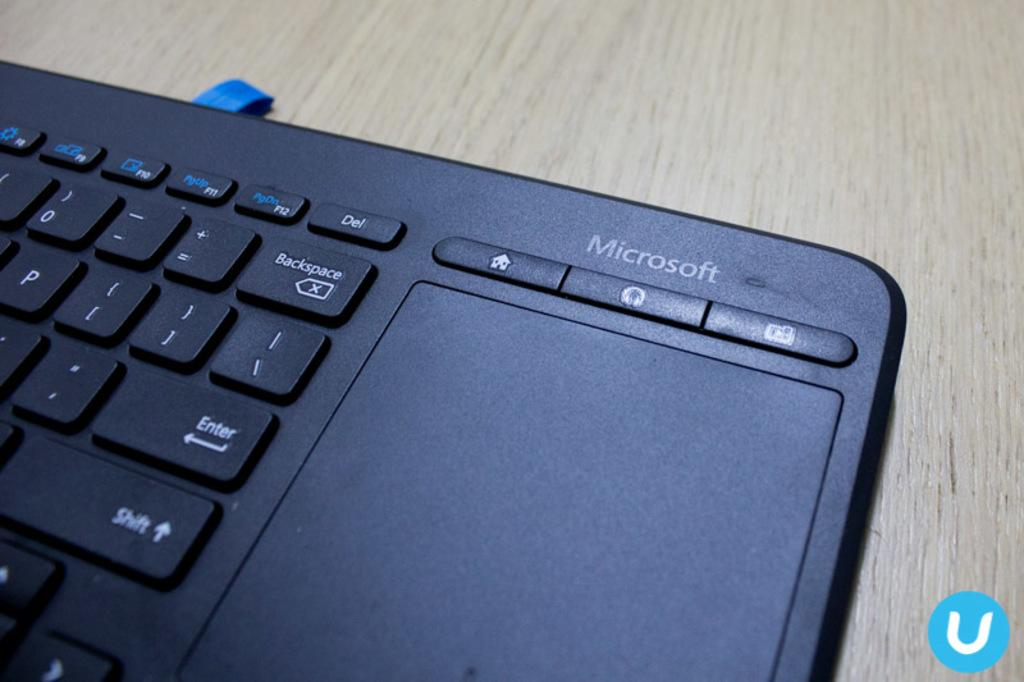<image>
Create a compact narrative representing the image presented. The black microsoft keyboard sits on a wooden table 